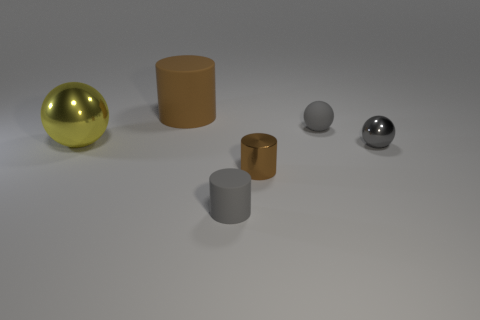Subtract all matte cylinders. How many cylinders are left? 1 Subtract all gray balls. How many balls are left? 1 Add 1 tiny red rubber cubes. How many objects exist? 7 Add 3 big balls. How many big balls exist? 4 Subtract 0 brown spheres. How many objects are left? 6 Subtract 1 cylinders. How many cylinders are left? 2 Subtract all green cylinders. Subtract all yellow cubes. How many cylinders are left? 3 Subtract all cyan balls. How many brown cylinders are left? 2 Subtract all big shiny blocks. Subtract all tiny gray metal things. How many objects are left? 5 Add 4 yellow metallic things. How many yellow metallic things are left? 5 